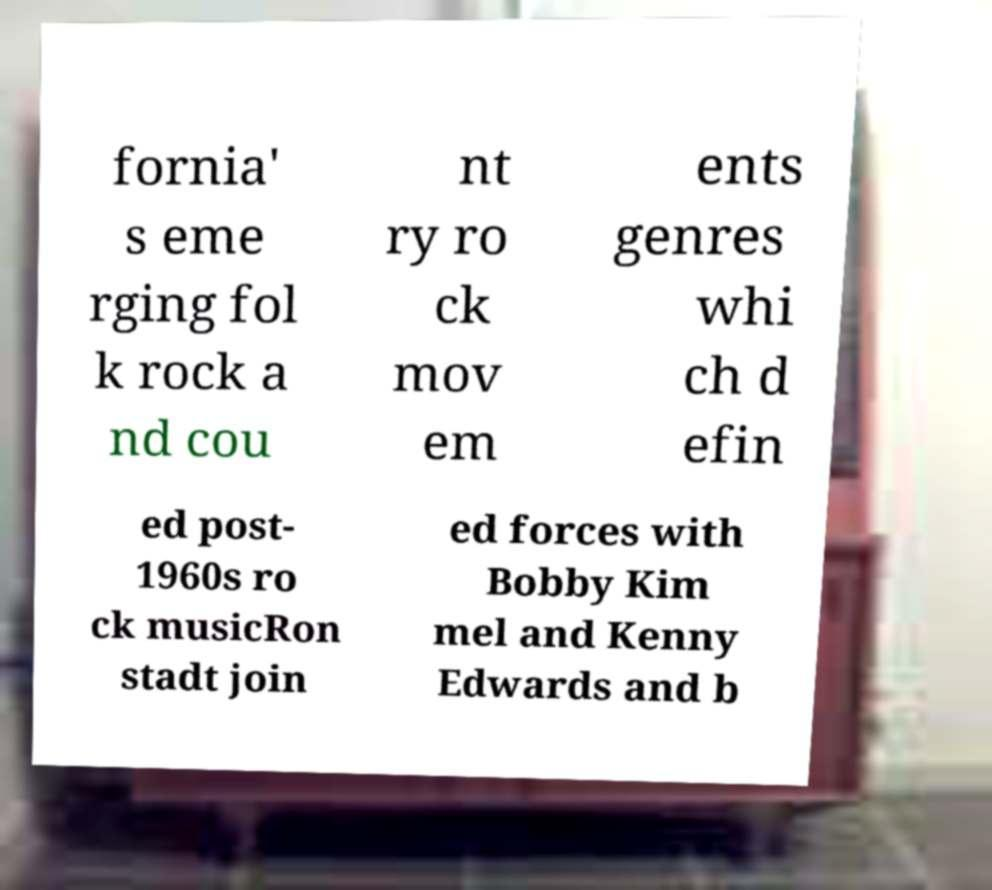Could you assist in decoding the text presented in this image and type it out clearly? fornia' s eme rging fol k rock a nd cou nt ry ro ck mov em ents genres whi ch d efin ed post- 1960s ro ck musicRon stadt join ed forces with Bobby Kim mel and Kenny Edwards and b 